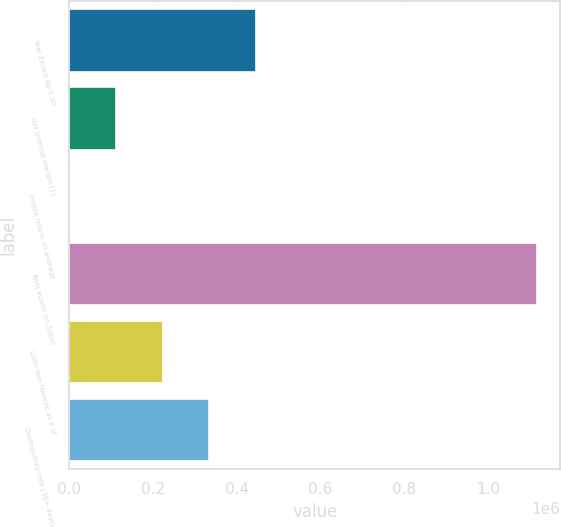Convert chart to OTSL. <chart><loc_0><loc_0><loc_500><loc_500><bar_chart><fcel>Year Ended April 30<fcel>Net interest margin (1)<fcel>Pretax return on average<fcel>Total assets (in 000s)<fcel>Loan loss reserve as a of<fcel>Delinquency rate (30+ days)<nl><fcel>446801<fcel>111701<fcel>1.03<fcel>1.117e+06<fcel>223401<fcel>335101<nl></chart> 